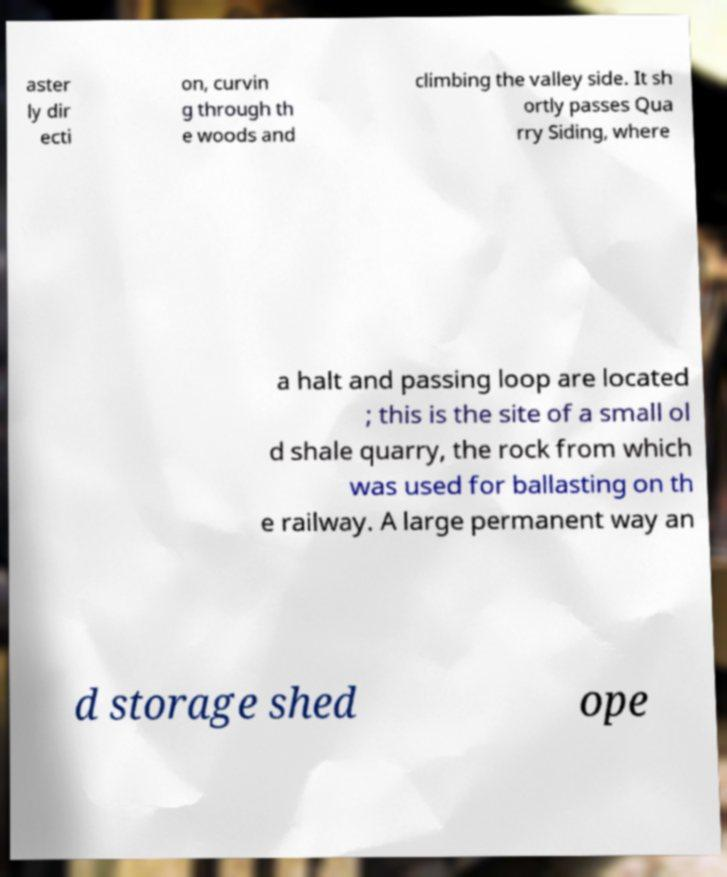Could you extract and type out the text from this image? aster ly dir ecti on, curvin g through th e woods and climbing the valley side. It sh ortly passes Qua rry Siding, where a halt and passing loop are located ; this is the site of a small ol d shale quarry, the rock from which was used for ballasting on th e railway. A large permanent way an d storage shed ope 